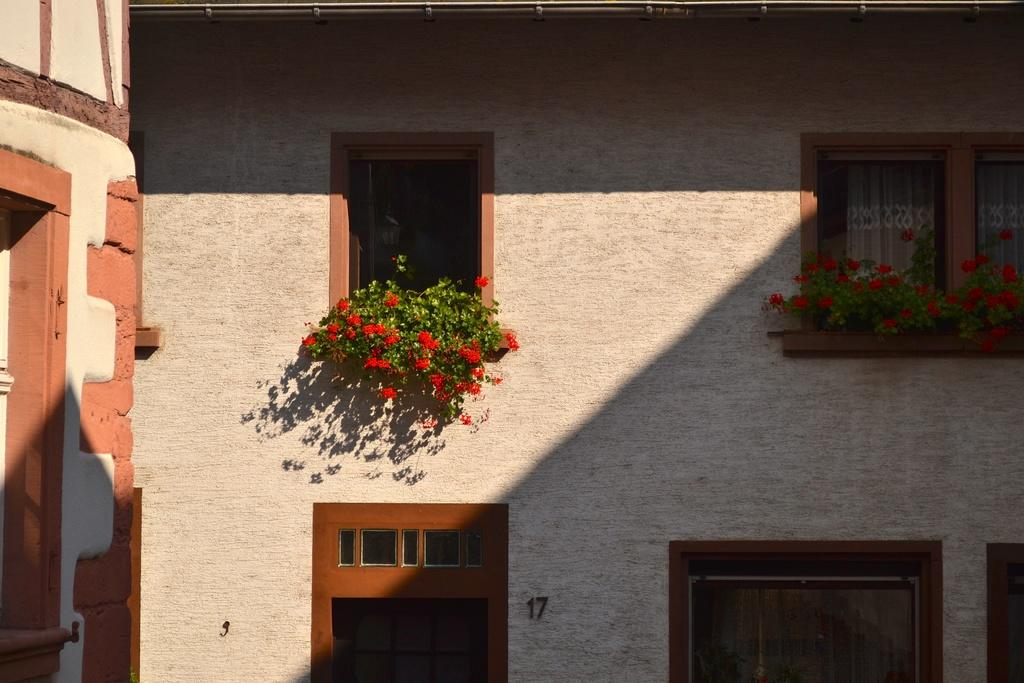What is the main subject in the center of the image? There is a building in the center of the image. What feature can be seen on the building? The building has windows. What type of decoration is present on the wall of the building? There are plants placed on the wall. How many balls are bouncing off the bridge in the image? There is no bridge or balls present in the image. 